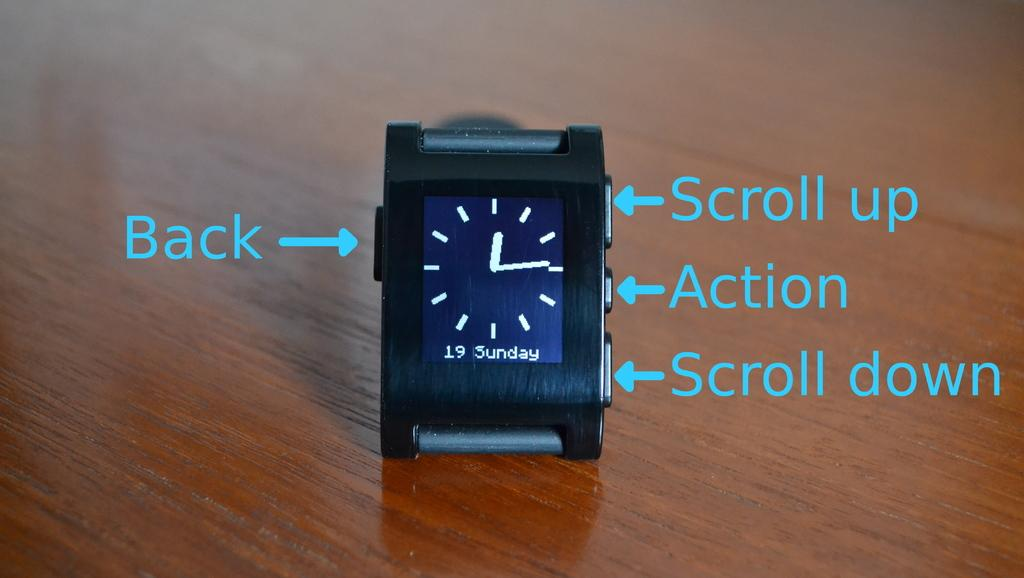<image>
Share a concise interpretation of the image provided. A tiny clock with instructions to scroll up, scroll down, action and Back written on the side of the picture. 